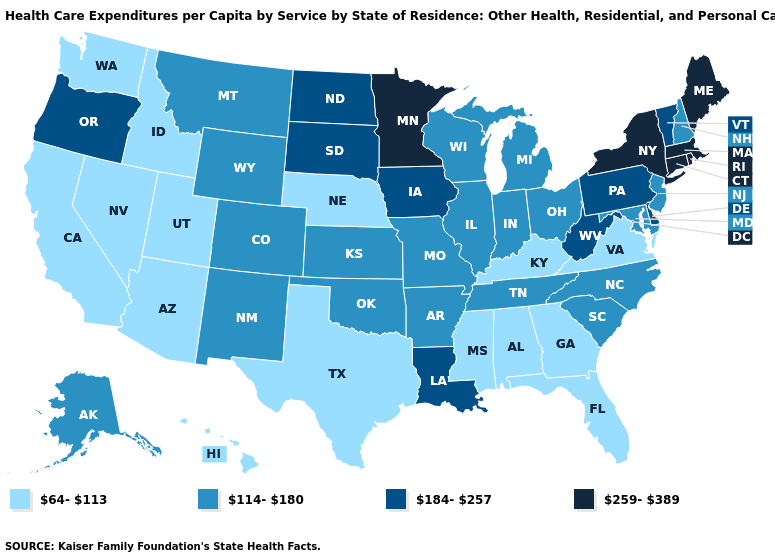Does the map have missing data?
Answer briefly. No. Does North Carolina have a higher value than Kansas?
Quick response, please. No. Name the states that have a value in the range 64-113?
Give a very brief answer. Alabama, Arizona, California, Florida, Georgia, Hawaii, Idaho, Kentucky, Mississippi, Nebraska, Nevada, Texas, Utah, Virginia, Washington. What is the value of Kansas?
Quick response, please. 114-180. Does the first symbol in the legend represent the smallest category?
Keep it brief. Yes. What is the value of Oregon?
Concise answer only. 184-257. Which states have the highest value in the USA?
Give a very brief answer. Connecticut, Maine, Massachusetts, Minnesota, New York, Rhode Island. Does Idaho have a lower value than West Virginia?
Keep it brief. Yes. Is the legend a continuous bar?
Short answer required. No. Name the states that have a value in the range 259-389?
Answer briefly. Connecticut, Maine, Massachusetts, Minnesota, New York, Rhode Island. Name the states that have a value in the range 184-257?
Write a very short answer. Delaware, Iowa, Louisiana, North Dakota, Oregon, Pennsylvania, South Dakota, Vermont, West Virginia. Does Massachusetts have the highest value in the USA?
Concise answer only. Yes. What is the value of Delaware?
Write a very short answer. 184-257. Among the states that border Texas , which have the lowest value?
Short answer required. Arkansas, New Mexico, Oklahoma. Name the states that have a value in the range 184-257?
Concise answer only. Delaware, Iowa, Louisiana, North Dakota, Oregon, Pennsylvania, South Dakota, Vermont, West Virginia. 